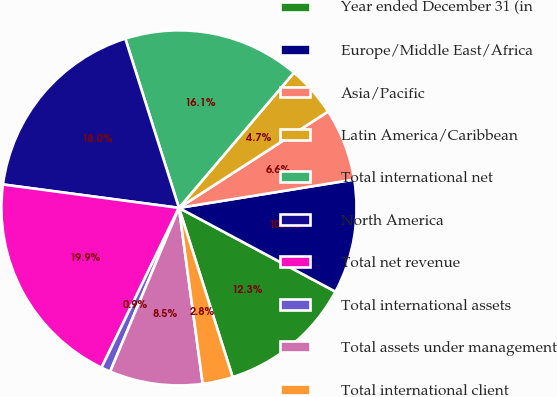<chart> <loc_0><loc_0><loc_500><loc_500><pie_chart><fcel>Year ended December 31 (in<fcel>Europe/Middle East/Africa<fcel>Asia/Pacific<fcel>Latin America/Caribbean<fcel>Total international net<fcel>North America<fcel>Total net revenue<fcel>Total international assets<fcel>Total assets under management<fcel>Total international client<nl><fcel>12.29%<fcel>10.38%<fcel>6.57%<fcel>4.66%<fcel>16.1%<fcel>18.01%<fcel>19.92%<fcel>0.85%<fcel>8.47%<fcel>2.75%<nl></chart> 